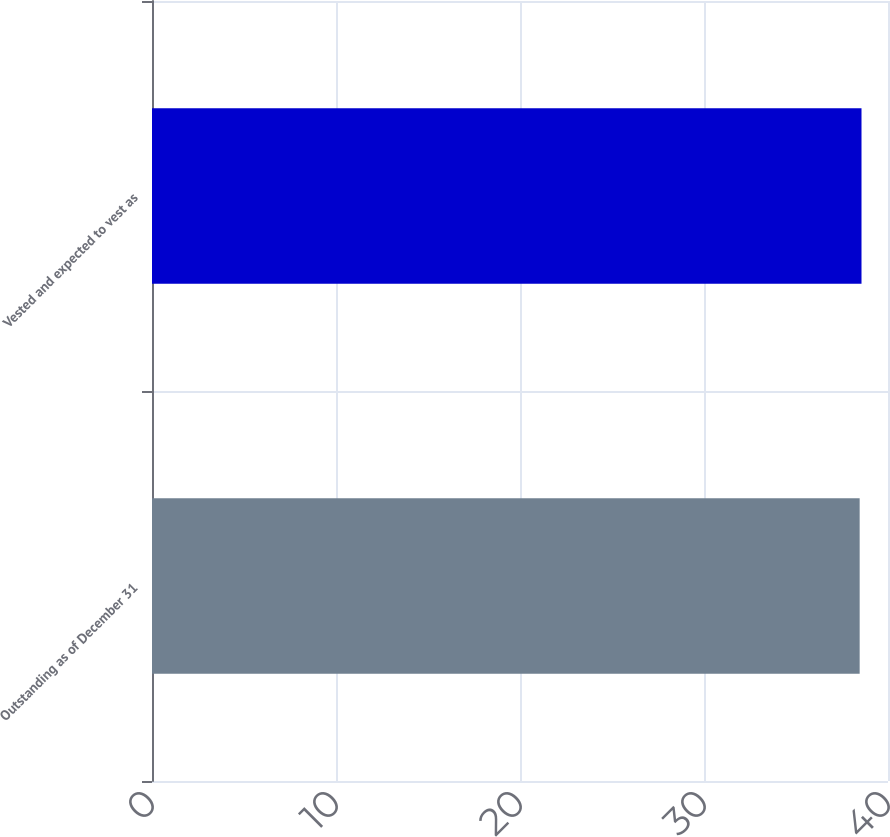Convert chart to OTSL. <chart><loc_0><loc_0><loc_500><loc_500><bar_chart><fcel>Outstanding as of December 31<fcel>Vested and expected to vest as<nl><fcel>38.46<fcel>38.56<nl></chart> 